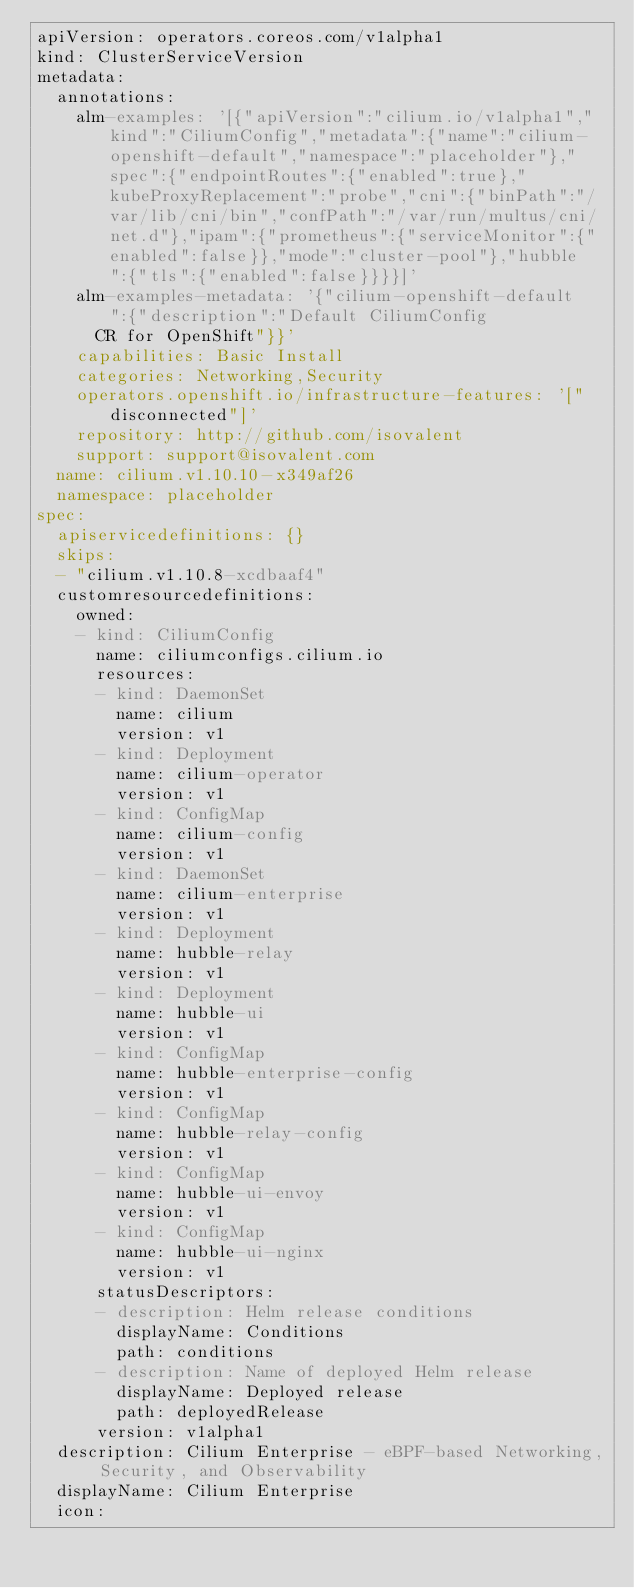Convert code to text. <code><loc_0><loc_0><loc_500><loc_500><_YAML_>apiVersion: operators.coreos.com/v1alpha1
kind: ClusterServiceVersion
metadata:
  annotations:
    alm-examples: '[{"apiVersion":"cilium.io/v1alpha1","kind":"CiliumConfig","metadata":{"name":"cilium-openshift-default","namespace":"placeholder"},"spec":{"endpointRoutes":{"enabled":true},"kubeProxyReplacement":"probe","cni":{"binPath":"/var/lib/cni/bin","confPath":"/var/run/multus/cni/net.d"},"ipam":{"prometheus":{"serviceMonitor":{"enabled":false}},"mode":"cluster-pool"},"hubble":{"tls":{"enabled":false}}}}]'
    alm-examples-metadata: '{"cilium-openshift-default":{"description":"Default CiliumConfig
      CR for OpenShift"}}'
    capabilities: Basic Install
    categories: Networking,Security
    operators.openshift.io/infrastructure-features: '["disconnected"]'
    repository: http://github.com/isovalent
    support: support@isovalent.com
  name: cilium.v1.10.10-x349af26
  namespace: placeholder
spec:
  apiservicedefinitions: {}
  skips:
  - "cilium.v1.10.8-xcdbaaf4"
  customresourcedefinitions:
    owned:
    - kind: CiliumConfig
      name: ciliumconfigs.cilium.io
      resources:
      - kind: DaemonSet
        name: cilium
        version: v1
      - kind: Deployment
        name: cilium-operator
        version: v1
      - kind: ConfigMap
        name: cilium-config
        version: v1
      - kind: DaemonSet
        name: cilium-enterprise
        version: v1
      - kind: Deployment
        name: hubble-relay
        version: v1
      - kind: Deployment
        name: hubble-ui
        version: v1
      - kind: ConfigMap
        name: hubble-enterprise-config
        version: v1
      - kind: ConfigMap
        name: hubble-relay-config
        version: v1
      - kind: ConfigMap
        name: hubble-ui-envoy
        version: v1
      - kind: ConfigMap
        name: hubble-ui-nginx
        version: v1
      statusDescriptors:
      - description: Helm release conditions
        displayName: Conditions
        path: conditions
      - description: Name of deployed Helm release
        displayName: Deployed release
        path: deployedRelease
      version: v1alpha1
  description: Cilium Enterprise - eBPF-based Networking, Security, and Observability
  displayName: Cilium Enterprise
  icon:</code> 